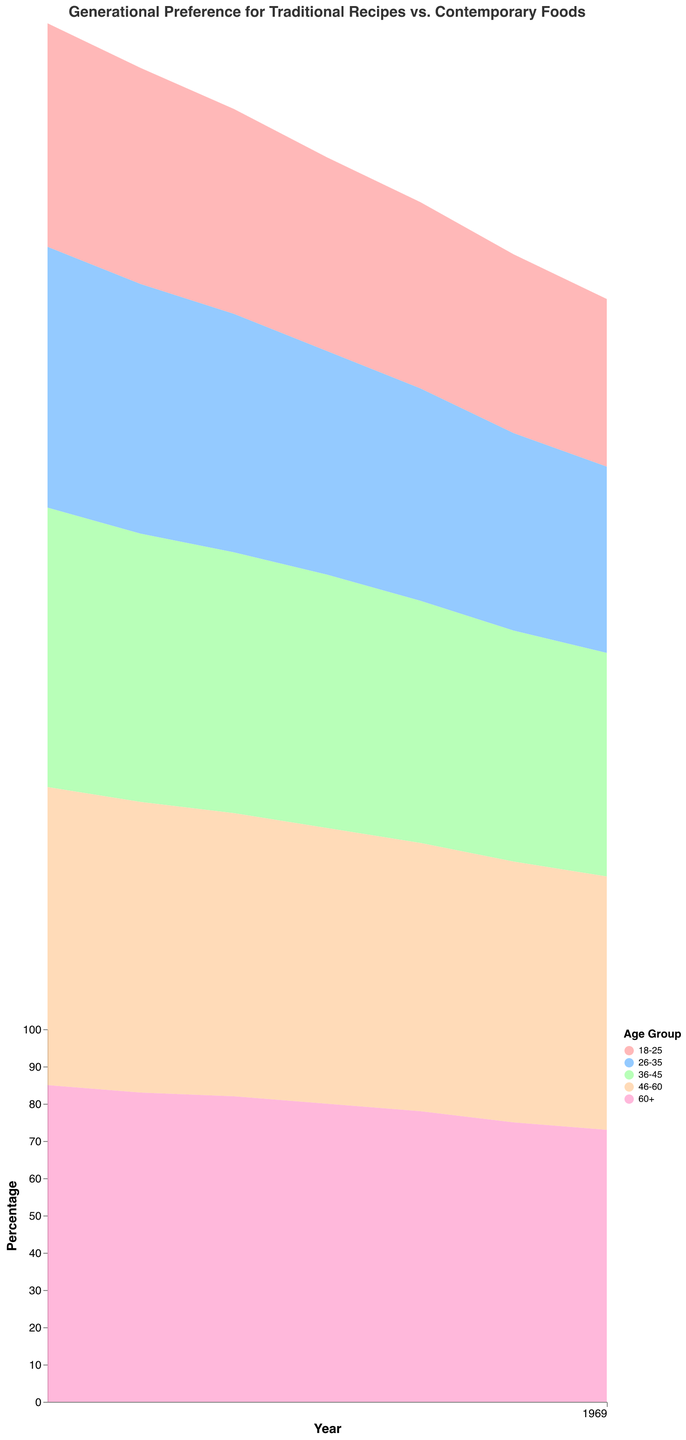What is the title of the chart? The title can be found at the top of the chart and reads "Generational Preference for Traditional Recipes vs. Contemporary Foods."
Answer: Generational Preference for Traditional Recipes vs. Contemporary Foods Which age group has the highest preference for traditional recipes in 2022? Check the data for 2022 and identify the age group with the highest percentage for traditional recipes. The 60+ age group has the highest preference at 73%.
Answer: 60+ How has the preference for traditional recipes changed for the 18-25 age group between 2010 and 2022? Look at the percentage of traditional recipes for the 18-25 age group in 2010 and 2022. In 2010, it's 60%, and in 2022, it's 45%. So the preference has decreased by 15 percentage points.
Answer: Decreased by 15 percentage points In which year did the 26-35 age group have an equal preference for traditional recipes and contemporary foods? Check the data for the 26-35 age group to find the year when both preferences were equal. It is in 2022 when both are at 50%.
Answer: 2022 Compare the trend of traditional recipes preference between the 36-45 and 46-60 age groups from 2010 to 2022. Examine the percentages for traditional recipes in both age groups from 2010 to 2022. Both groups show a decreasing trend, but the 36-45 group starts at 75% and ends at 60%, while the 46-60 group starts at 80% and ends at 68%. Therefore, traditional recipes preference decreased more in the 36-45 age group.
Answer: Both decreased, 36-45 decreased more What is the average preference for traditional recipes for the 60+ age group across all years shown? Sum all the yearly percentages of traditional recipes for the 60+ age group and divide by the number of years (7). (85+83+82+80+78+75+73)/7 = 79.43
Answer: 79.43 Which age group shows the least change in preference for contemporary foods from 2010 to 2022? Compare the changes in contemporary foods preferences for all age groups from 2010 to 2022. The 60+ age group's preference for contemporary foods changes from 15% to 27%, which is an increase of 12 percentage points, the smallest change among all age groups.
Answer: 60+ In which years did the 46-60 age group prefer traditional recipes more than contemporary foods? Check the data for the 46-60 age group and identify the years when the percentage for traditional recipes is higher than contemporary foods. This happens in all years shown (2010 to 2022).
Answer: 2010 to 2022 How did the preference for contemporary foods change for the 36-45 age group from 2010 to 2022? Look at the percentage of contemporary foods for the 36-45 age group in 2010 and 2022. In 2010, it's 25%, and in 2022, it's 40%. So the preference has increased by 15 percentage points.
Answer: Increased by 15 percentage points 